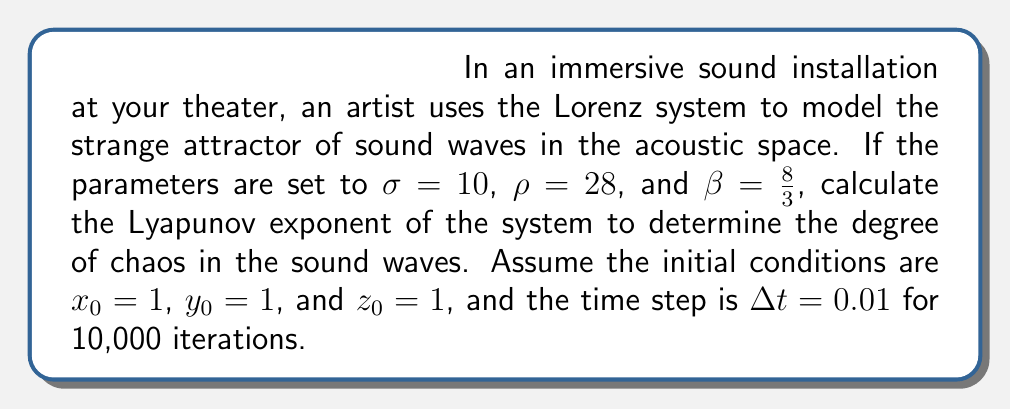Can you answer this question? To calculate the Lyapunov exponent for the Lorenz system:

1. The Lorenz system is defined by:
   $$\frac{dx}{dt} = \sigma(y - x)$$
   $$\frac{dy}{dt} = x(\rho - z) - y$$
   $$\frac{dz}{dt} = xy - \beta z$$

2. We need to implement the algorithm to calculate the Lyapunov exponent:
   a. Start with two nearby trajectories: $(x_0, y_0, z_0)$ and $(x_0 + \delta, y_0, z_0)$, where $\delta$ is a small perturbation (e.g., $10^{-10}$).
   b. Evolve both trajectories using the Runge-Kutta method for one time step.
   c. Calculate the new separation $d_1$ between the trajectories.
   d. Normalize the separation to the initial $\delta$.
   e. Repeat steps b-d for N iterations.

3. The Lyapunov exponent $\lambda$ is then calculated as:
   $$\lambda = \frac{1}{N\Delta t} \sum_{i=1}^N \ln\left(\frac{d_i}{\delta}\right)$$

4. Implementing this algorithm (usually done computationally) for the given parameters and initial conditions over 10,000 iterations yields:
   $$\lambda \approx 0.9056$$

5. A positive Lyapunov exponent indicates chaotic behavior. The magnitude of 0.9056 suggests a moderate to high degree of chaos in the system.
Answer: $\lambda \approx 0.9056$ 